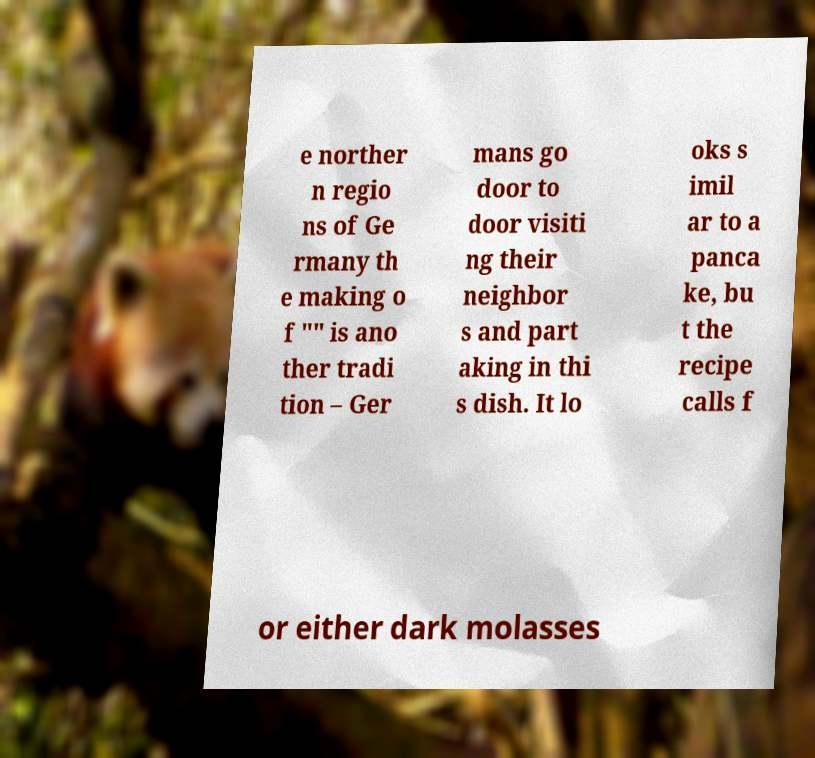Please read and relay the text visible in this image. What does it say? e norther n regio ns of Ge rmany th e making o f "" is ano ther tradi tion – Ger mans go door to door visiti ng their neighbor s and part aking in thi s dish. It lo oks s imil ar to a panca ke, bu t the recipe calls f or either dark molasses 